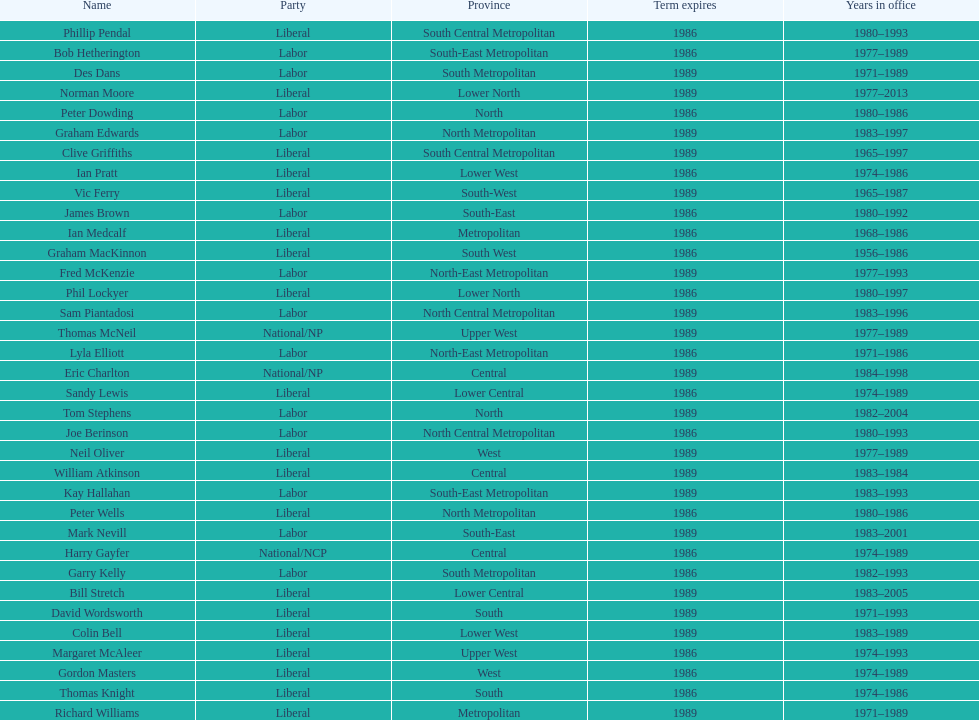Hame the last member listed whose last name begins with "p". Ian Pratt. 